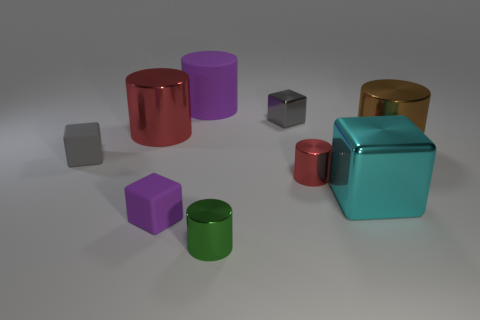Subtract all red cylinders. How many cylinders are left? 3 Subtract all big red metal cylinders. How many cylinders are left? 4 Add 1 tiny red things. How many objects exist? 10 Subtract 2 cylinders. How many cylinders are left? 3 Subtract 0 gray cylinders. How many objects are left? 9 Subtract all cubes. How many objects are left? 5 Subtract all blue blocks. Subtract all yellow balls. How many blocks are left? 4 Subtract all blue blocks. How many brown cylinders are left? 1 Subtract all brown shiny objects. Subtract all large brown objects. How many objects are left? 7 Add 1 small gray shiny objects. How many small gray shiny objects are left? 2 